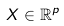<formula> <loc_0><loc_0><loc_500><loc_500>X \in \mathbb { R } ^ { p }</formula> 